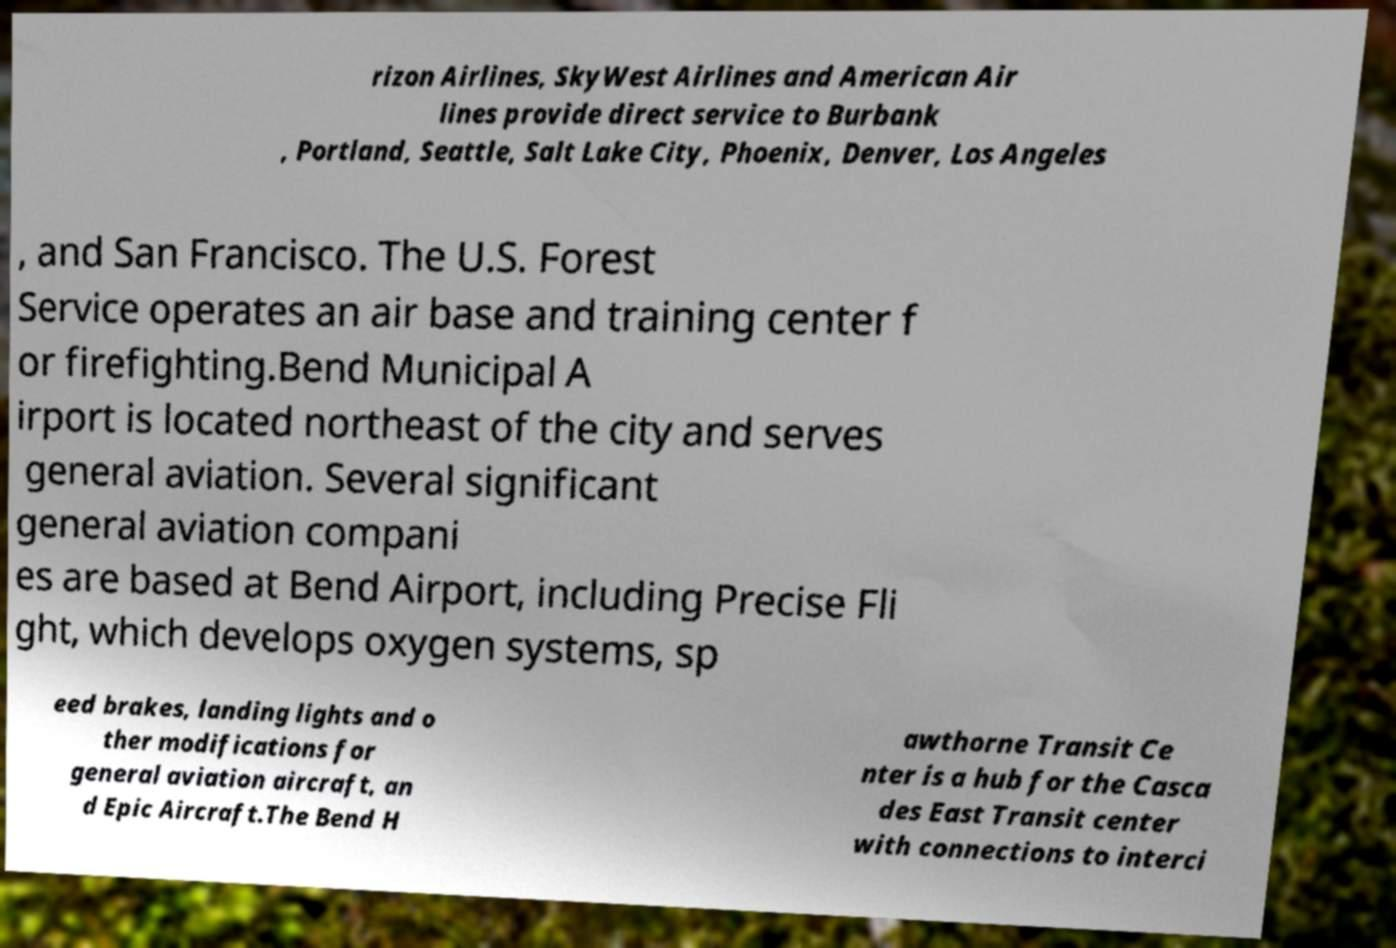Can you accurately transcribe the text from the provided image for me? rizon Airlines, SkyWest Airlines and American Air lines provide direct service to Burbank , Portland, Seattle, Salt Lake City, Phoenix, Denver, Los Angeles , and San Francisco. The U.S. Forest Service operates an air base and training center f or firefighting.Bend Municipal A irport is located northeast of the city and serves general aviation. Several significant general aviation compani es are based at Bend Airport, including Precise Fli ght, which develops oxygen systems, sp eed brakes, landing lights and o ther modifications for general aviation aircraft, an d Epic Aircraft.The Bend H awthorne Transit Ce nter is a hub for the Casca des East Transit center with connections to interci 